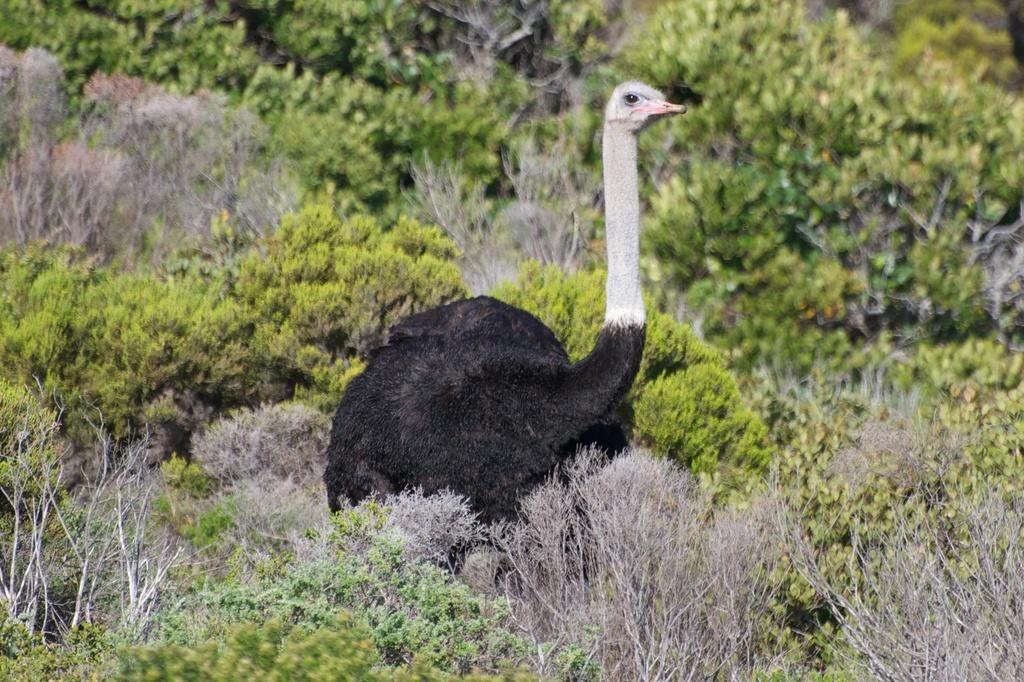What animal is the main subject of the picture? There is an ostrich in the picture. What is the ostrich's location in relation to other objects in the image? The ostrich is standing near plants. What can be seen in the background of the picture? There are trees in the background of the picture. What type of soup is being served in the image? There is no soup present in the image; it features an ostrich standing near plants with trees in the background. Can you see a chain attached to the ostrich in the image? There is no chain visible in the image; it only shows an ostrich standing near plants with trees in the background. 